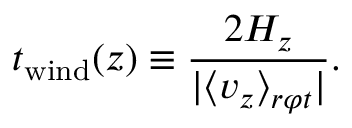Convert formula to latex. <formula><loc_0><loc_0><loc_500><loc_500>t _ { w i n d } ( z ) \equiv \frac { 2 H _ { z } } { | \langle v _ { z } \rangle _ { r \varphi t } | } .</formula> 